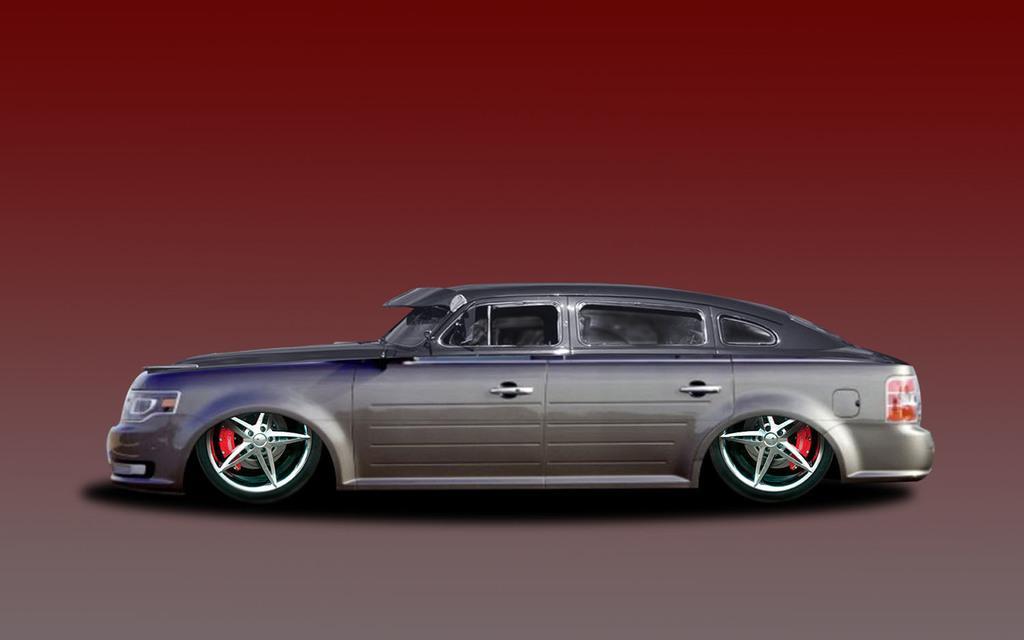Can you describe this image briefly? In this image there is a car, in the background there is brown color. 